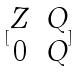Convert formula to latex. <formula><loc_0><loc_0><loc_500><loc_500>[ \begin{matrix} Z & Q \\ 0 & Q \end{matrix} ]</formula> 